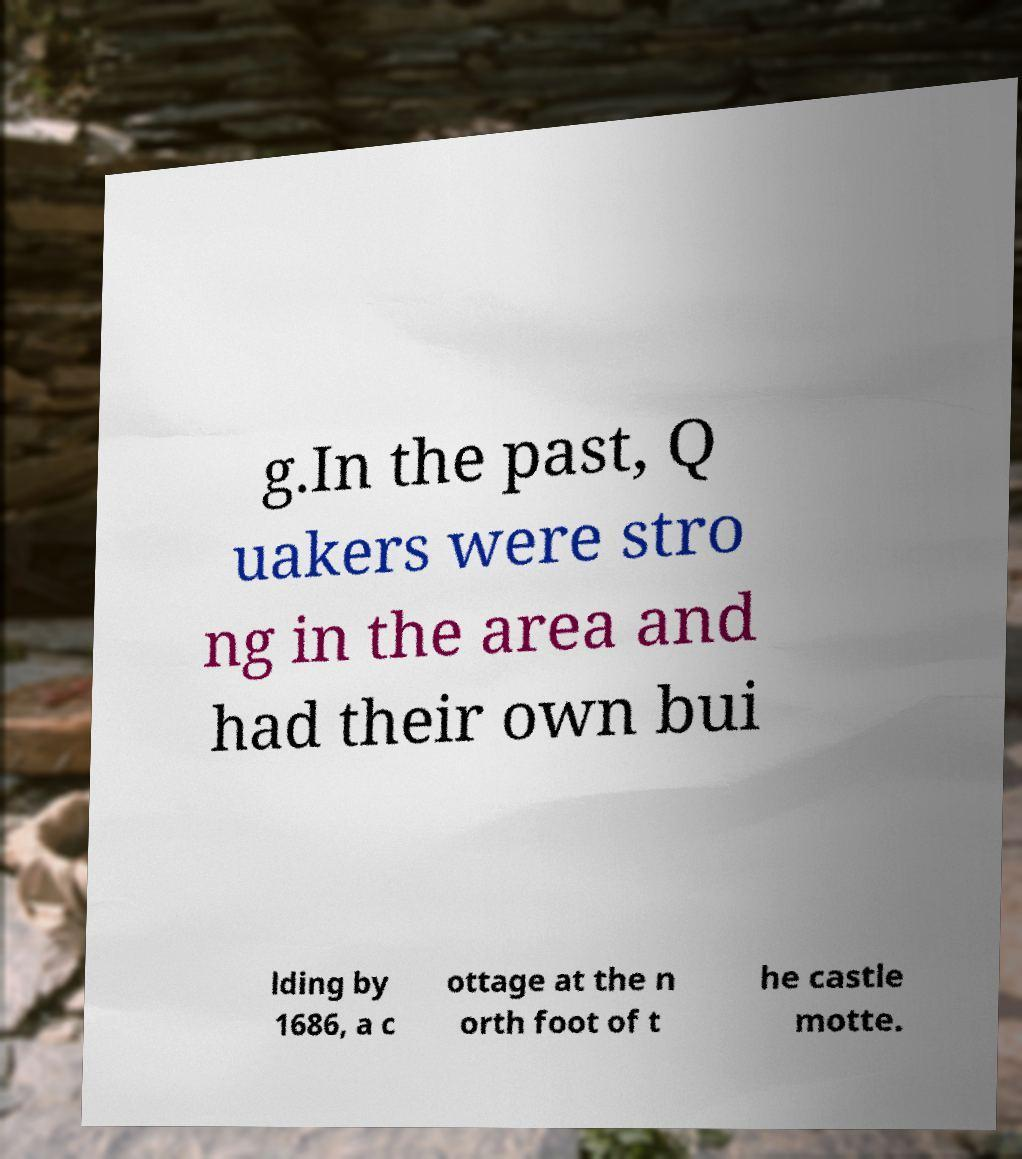Can you read and provide the text displayed in the image?This photo seems to have some interesting text. Can you extract and type it out for me? g.In the past, Q uakers were stro ng in the area and had their own bui lding by 1686, a c ottage at the n orth foot of t he castle motte. 